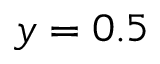<formula> <loc_0><loc_0><loc_500><loc_500>y = 0 . 5</formula> 